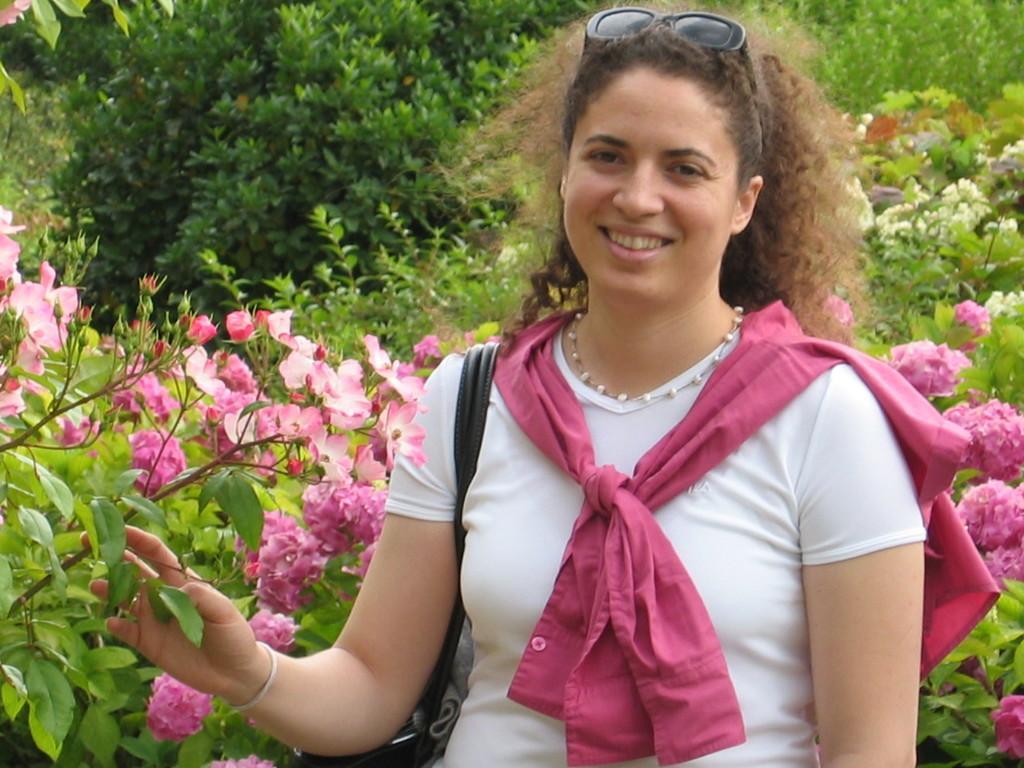Please provide a concise description of this image. In the image I can see a lady who is holding the stem to which there are some flowers and also I can see some trees and plants to which there are some flowers. 